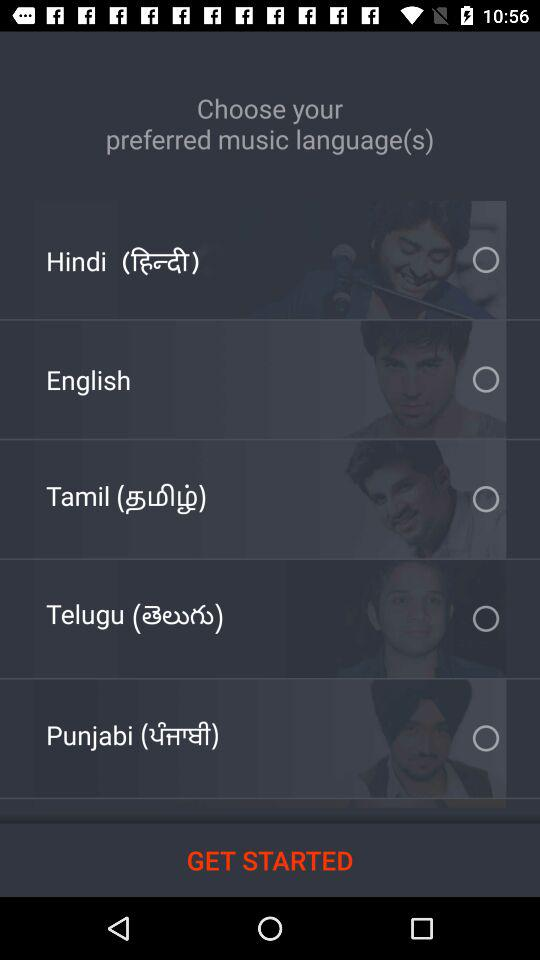What are the languages I can choose for music? The languages are "Hindi", "English", "Tamil", "Telugu" and "Punjabi". 